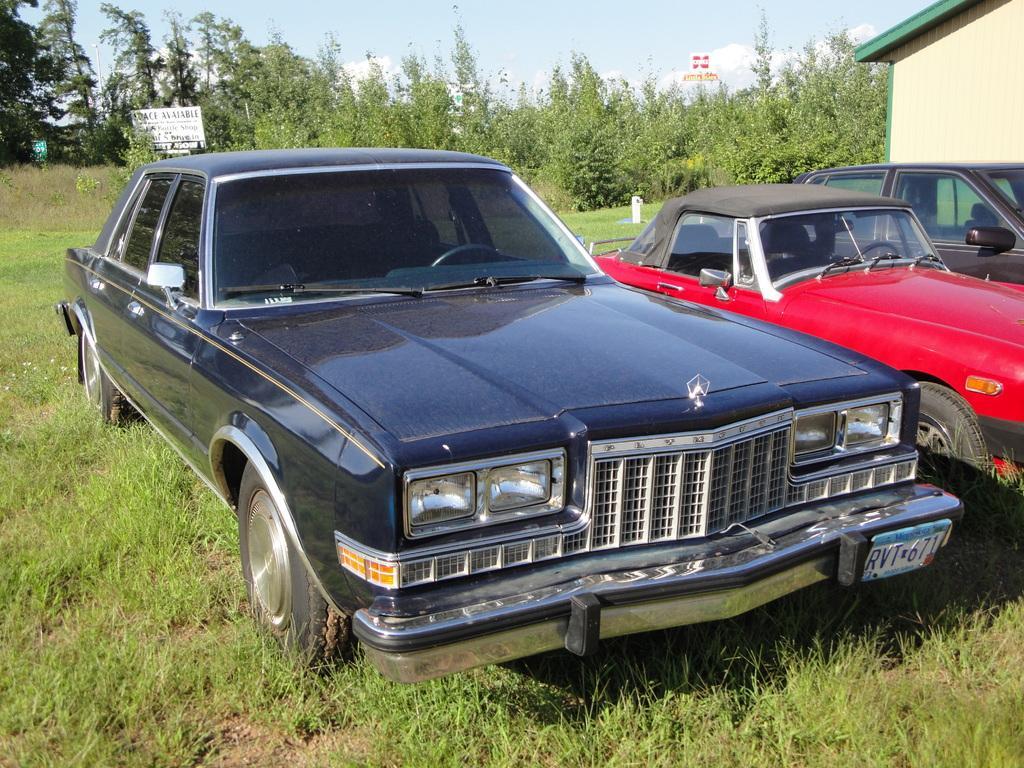How would you summarize this image in a sentence or two? In this image we can see a few vehicles on the ground, there are some plants, boards, trees, plants and a building, in the background we can see the sky with clouds. 